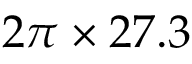<formula> <loc_0><loc_0><loc_500><loc_500>2 \pi \times 2 7 . 3</formula> 